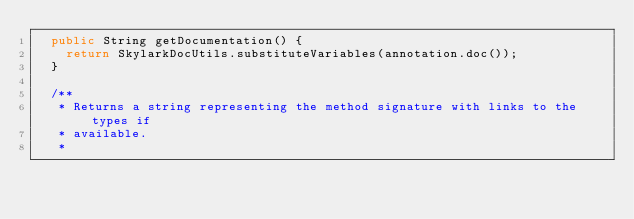Convert code to text. <code><loc_0><loc_0><loc_500><loc_500><_Java_>  public String getDocumentation() {
    return SkylarkDocUtils.substituteVariables(annotation.doc());
  }

  /**
   * Returns a string representing the method signature with links to the types if
   * available.
   *</code> 